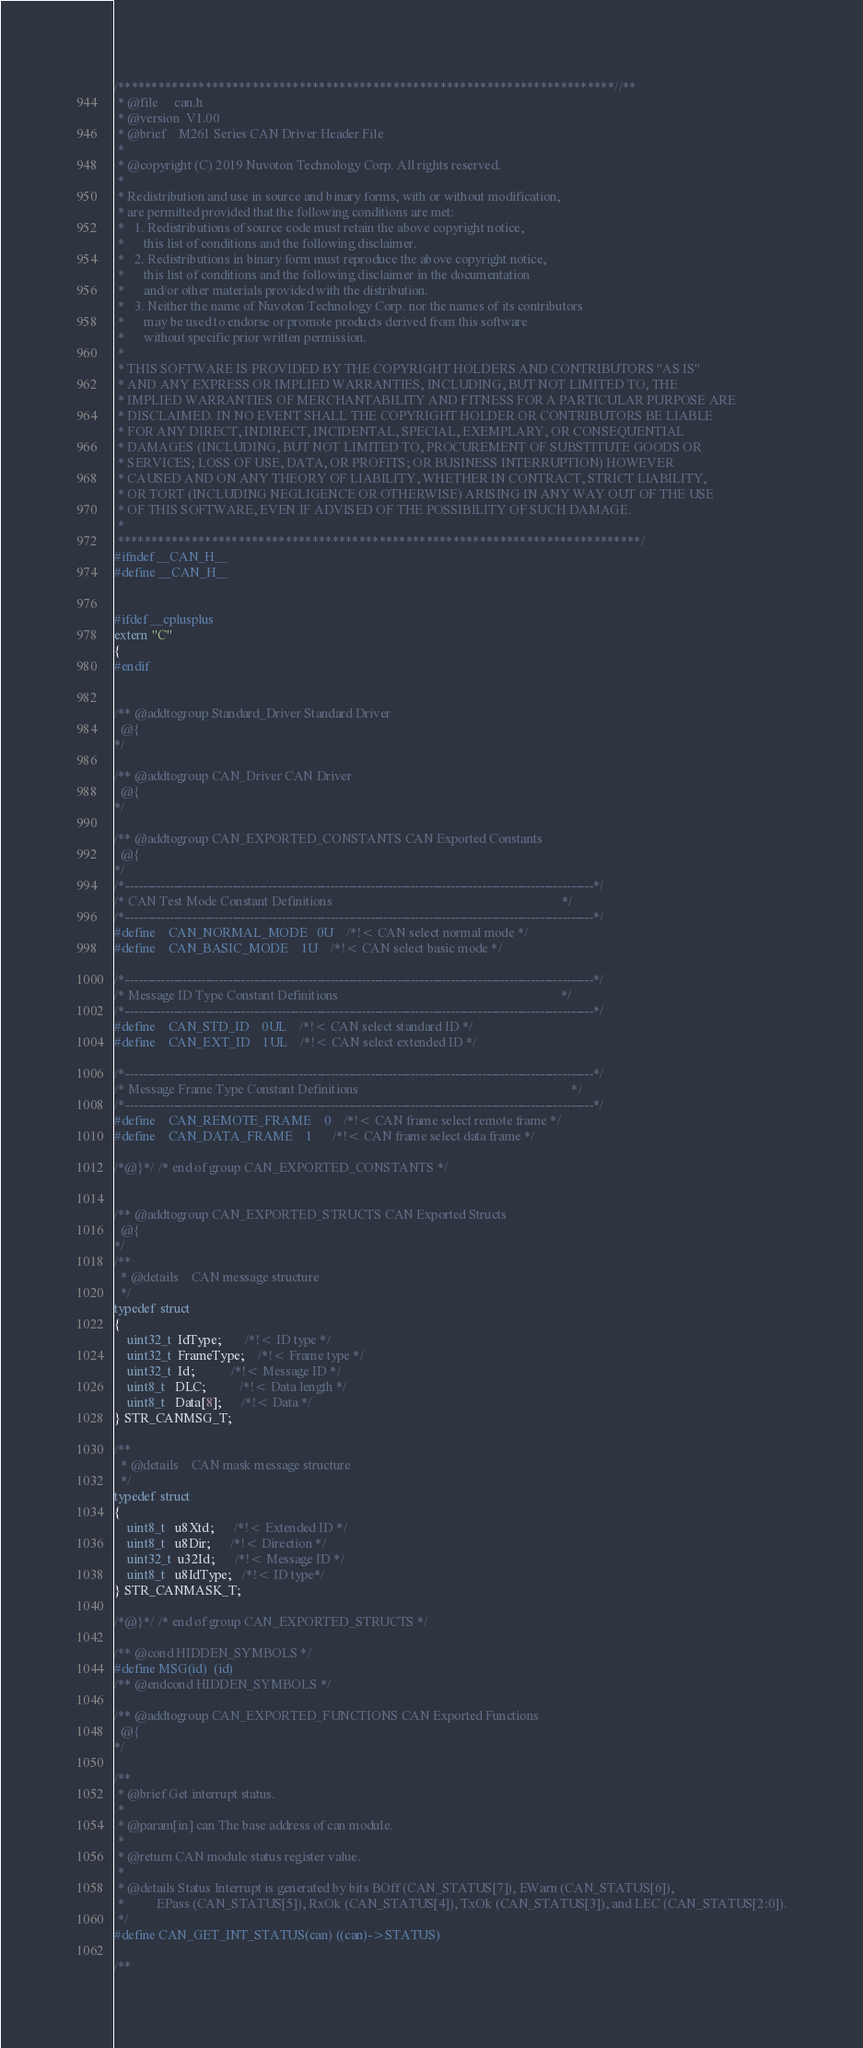Convert code to text. <code><loc_0><loc_0><loc_500><loc_500><_C_>/**************************************************************************//**
 * @file     can.h
 * @version  V1.00
 * @brief    M261 Series CAN Driver Header File
 *
 * @copyright (C) 2019 Nuvoton Technology Corp. All rights reserved.
 * 
 * Redistribution and use in source and binary forms, with or without modification,
 * are permitted provided that the following conditions are met:
 *   1. Redistributions of source code must retain the above copyright notice,
 *      this list of conditions and the following disclaimer.
 *   2. Redistributions in binary form must reproduce the above copyright notice,
 *      this list of conditions and the following disclaimer in the documentation
 *      and/or other materials provided with the distribution.
 *   3. Neither the name of Nuvoton Technology Corp. nor the names of its contributors
 *      may be used to endorse or promote products derived from this software
 *      without specific prior written permission.
 * 
 * THIS SOFTWARE IS PROVIDED BY THE COPYRIGHT HOLDERS AND CONTRIBUTORS "AS IS"
 * AND ANY EXPRESS OR IMPLIED WARRANTIES, INCLUDING, BUT NOT LIMITED TO, THE
 * IMPLIED WARRANTIES OF MERCHANTABILITY AND FITNESS FOR A PARTICULAR PURPOSE ARE
 * DISCLAIMED. IN NO EVENT SHALL THE COPYRIGHT HOLDER OR CONTRIBUTORS BE LIABLE
 * FOR ANY DIRECT, INDIRECT, INCIDENTAL, SPECIAL, EXEMPLARY, OR CONSEQUENTIAL
 * DAMAGES (INCLUDING, BUT NOT LIMITED TO, PROCUREMENT OF SUBSTITUTE GOODS OR
 * SERVICES; LOSS OF USE, DATA, OR PROFITS; OR BUSINESS INTERRUPTION) HOWEVER
 * CAUSED AND ON ANY THEORY OF LIABILITY, WHETHER IN CONTRACT, STRICT LIABILITY,
 * OR TORT (INCLUDING NEGLIGENCE OR OTHERWISE) ARISING IN ANY WAY OUT OF THE USE
 * OF THIS SOFTWARE, EVEN IF ADVISED OF THE POSSIBILITY OF SUCH DAMAGE.
 *
 ******************************************************************************/
#ifndef __CAN_H__
#define __CAN_H__


#ifdef __cplusplus
extern "C"
{
#endif


/** @addtogroup Standard_Driver Standard Driver
  @{
*/

/** @addtogroup CAN_Driver CAN Driver
  @{
*/

/** @addtogroup CAN_EXPORTED_CONSTANTS CAN Exported Constants
  @{
*/
/*---------------------------------------------------------------------------------------------------------*/
/* CAN Test Mode Constant Definitions                                                                      */
/*---------------------------------------------------------------------------------------------------------*/
#define    CAN_NORMAL_MODE   0U    /*!< CAN select normal mode */
#define    CAN_BASIC_MODE    1U    /*!< CAN select basic mode */

/*---------------------------------------------------------------------------------------------------------*/
/* Message ID Type Constant Definitions                                                                    */
/*---------------------------------------------------------------------------------------------------------*/
#define    CAN_STD_ID    0UL    /*!< CAN select standard ID */
#define    CAN_EXT_ID    1UL    /*!< CAN select extended ID */

/*---------------------------------------------------------------------------------------------------------*/
/* Message Frame Type Constant Definitions                                                                 */
/*---------------------------------------------------------------------------------------------------------*/
#define    CAN_REMOTE_FRAME    0    /*!< CAN frame select remote frame */
#define    CAN_DATA_FRAME    1      /*!< CAN frame select data frame */

/*@}*/ /* end of group CAN_EXPORTED_CONSTANTS */


/** @addtogroup CAN_EXPORTED_STRUCTS CAN Exported Structs
  @{
*/
/**
  * @details    CAN message structure
  */
typedef struct
{
    uint32_t  IdType;       /*!< ID type */
    uint32_t  FrameType;    /*!< Frame type */
    uint32_t  Id;           /*!< Message ID */
    uint8_t   DLC;          /*!< Data length */
    uint8_t   Data[8];      /*!< Data */
} STR_CANMSG_T;

/**
  * @details    CAN mask message structure
  */
typedef struct
{
    uint8_t   u8Xtd;      /*!< Extended ID */
    uint8_t   u8Dir;      /*!< Direction */
    uint32_t  u32Id;      /*!< Message ID */
    uint8_t   u8IdType;   /*!< ID type*/
} STR_CANMASK_T;

/*@}*/ /* end of group CAN_EXPORTED_STRUCTS */

/** @cond HIDDEN_SYMBOLS */
#define MSG(id)  (id)
/** @endcond HIDDEN_SYMBOLS */

/** @addtogroup CAN_EXPORTED_FUNCTIONS CAN Exported Functions
  @{
*/

/**
 * @brief Get interrupt status.
 *
 * @param[in] can The base address of can module.
 *
 * @return CAN module status register value.
 *
 * @details Status Interrupt is generated by bits BOff (CAN_STATUS[7]), EWarn (CAN_STATUS[6]),
 *          EPass (CAN_STATUS[5]), RxOk (CAN_STATUS[4]), TxOk (CAN_STATUS[3]), and LEC (CAN_STATUS[2:0]).
 */
#define CAN_GET_INT_STATUS(can) ((can)->STATUS)

/**</code> 